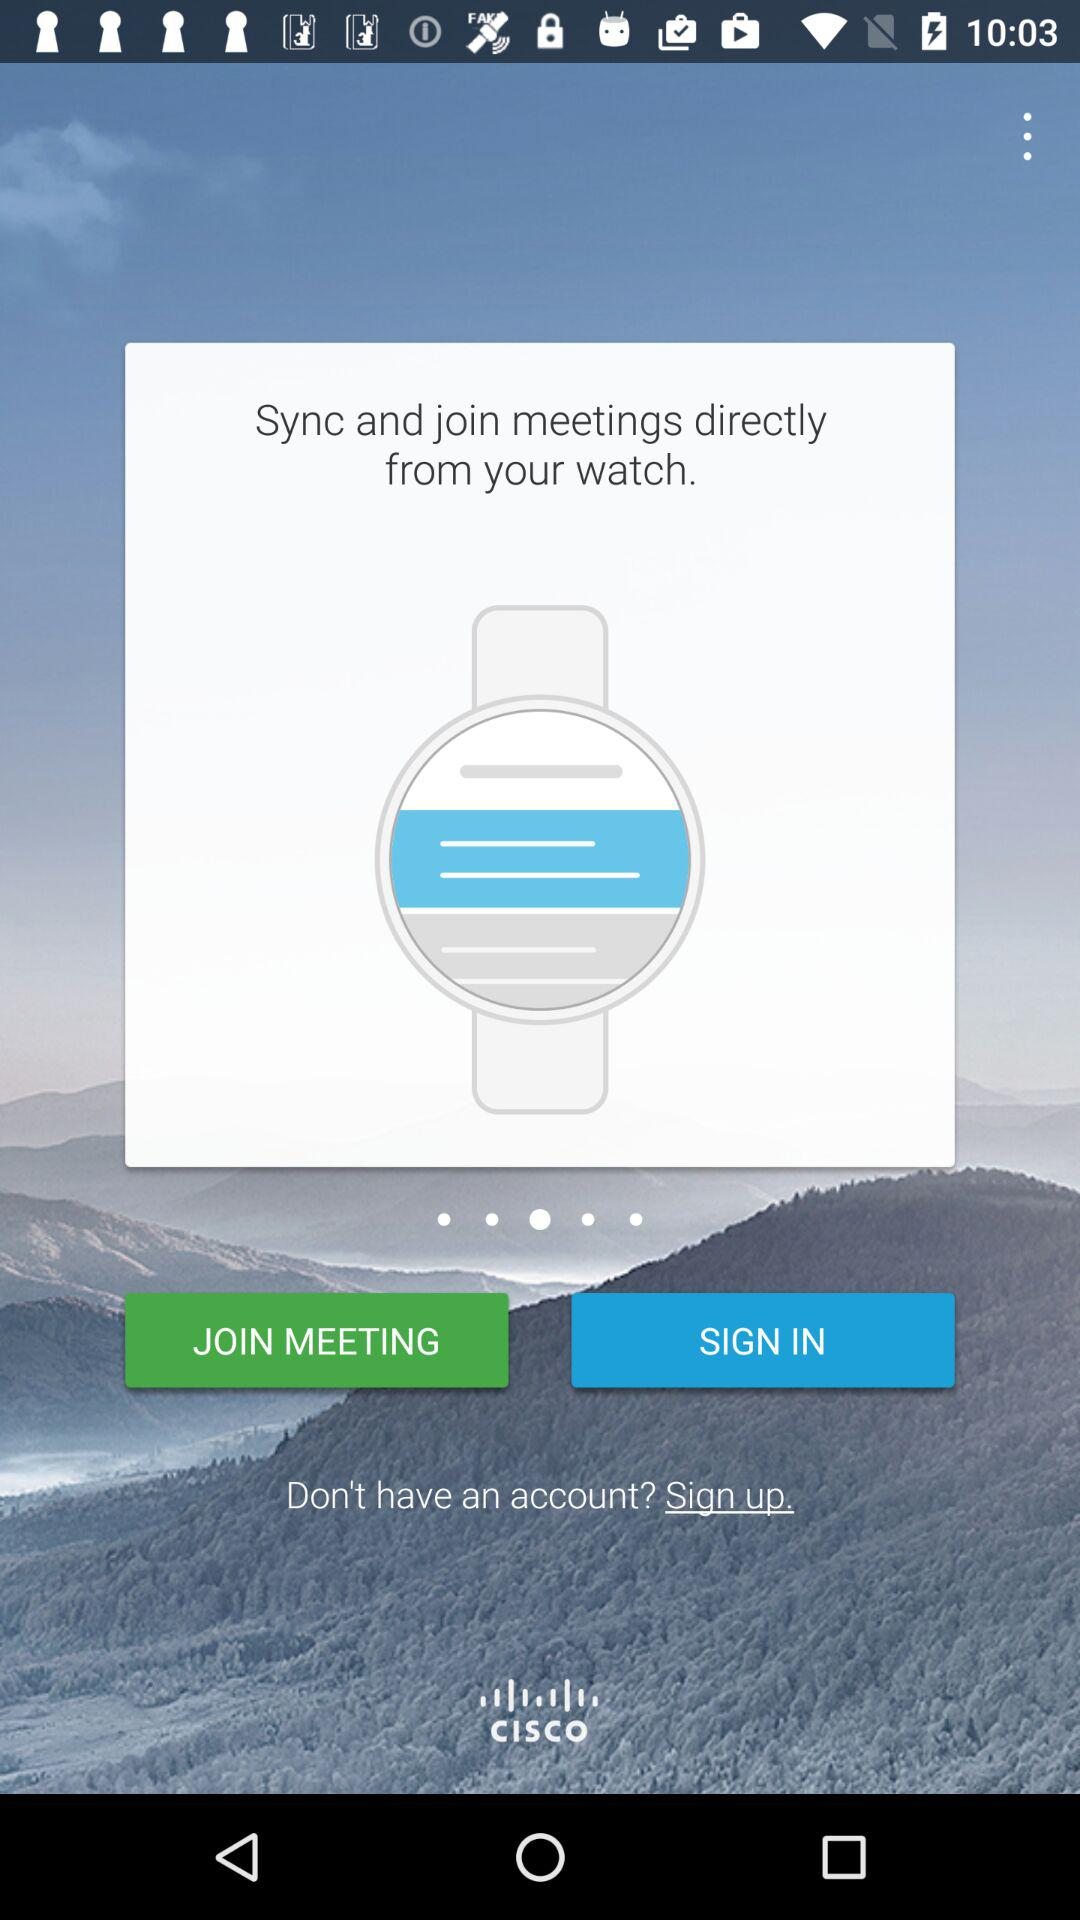Through whom will be signed?
When the provided information is insufficient, respond with <no answer>. <no answer> 